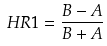<formula> <loc_0><loc_0><loc_500><loc_500>H R 1 = \frac { B - A } { B + A }</formula> 